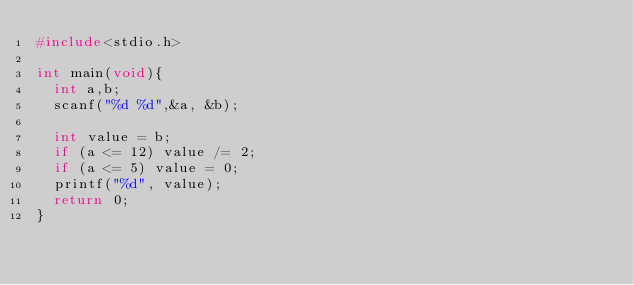Convert code to text. <code><loc_0><loc_0><loc_500><loc_500><_C_>#include<stdio.h>

int main(void){
  int a,b;
  scanf("%d %d",&a, &b);
  
  int value = b;
  if (a <= 12) value /= 2;
  if (a <= 5) value = 0;
  printf("%d", value);
  return 0;
}</code> 